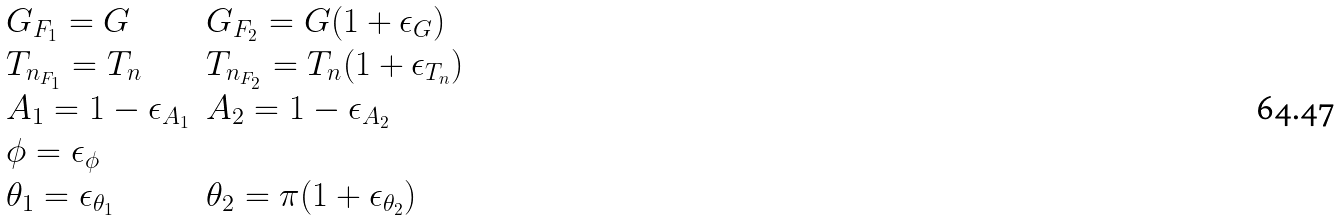Convert formula to latex. <formula><loc_0><loc_0><loc_500><loc_500>\begin{array} { l l } G _ { F _ { 1 } } = G & G _ { F _ { 2 } } = G ( 1 + \epsilon _ { G } ) \\ T _ { n _ { F _ { 1 } } } = T _ { n } & T _ { n _ { F _ { 2 } } } = T _ { n } ( 1 + \epsilon _ { T _ { n } } ) \\ A _ { 1 } = 1 - \epsilon _ { A _ { 1 } } & A _ { 2 } = 1 - \epsilon _ { A _ { 2 } } \\ \phi = \epsilon _ { \phi } \\ \theta _ { 1 } = \epsilon _ { \theta _ { 1 } } & \theta _ { 2 } = \pi ( 1 + \epsilon _ { \theta _ { 2 } } ) \end{array}</formula> 